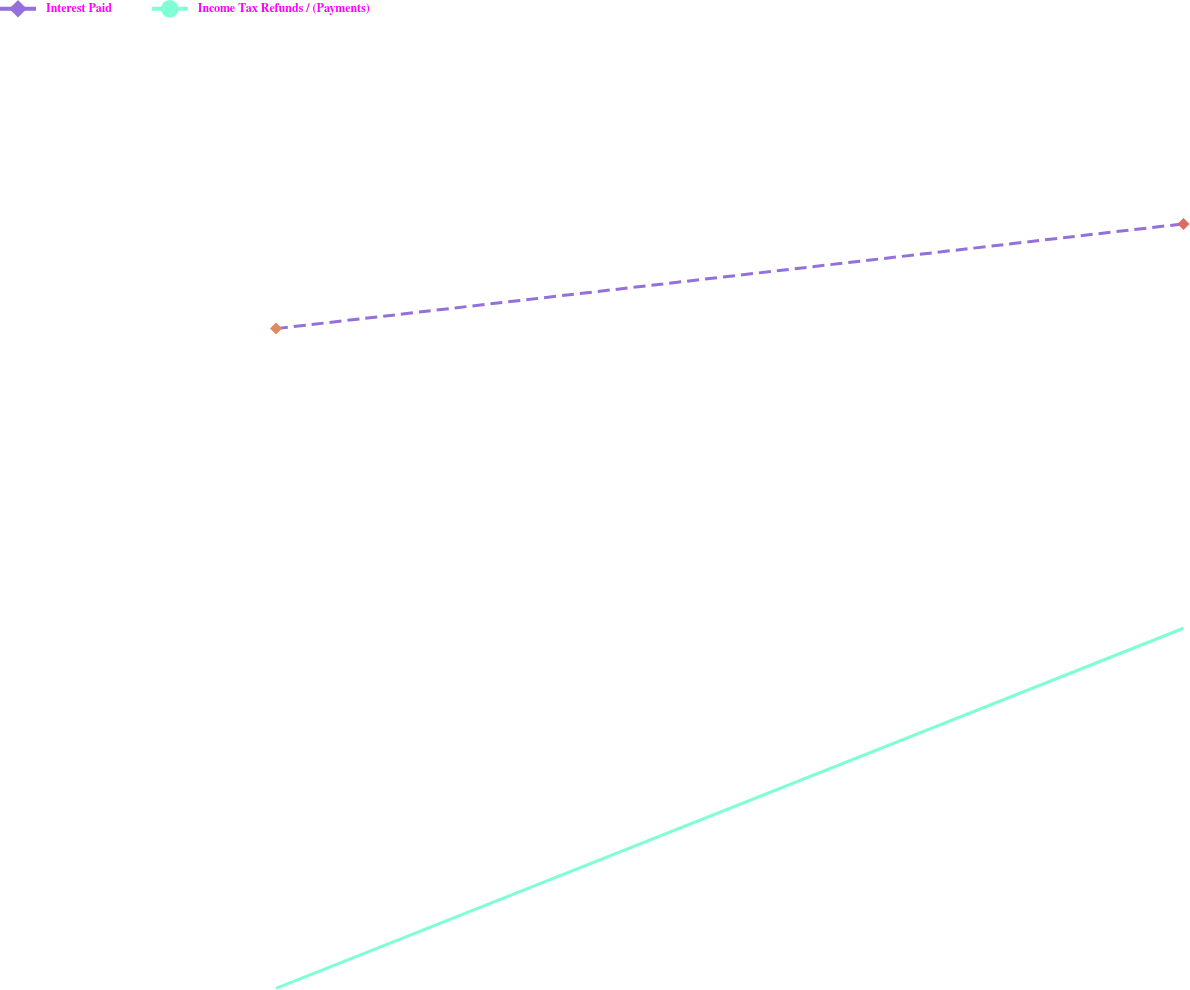Convert chart. <chart><loc_0><loc_0><loc_500><loc_500><line_chart><ecel><fcel>Interest Paid<fcel>Income Tax Refunds / (Payments)<nl><fcel>1730.75<fcel>308.91<fcel>34.03<nl><fcel>1870.94<fcel>352.55<fcel>184.07<nl><fcel>1928.48<fcel>397.39<fcel>64.75<nl></chart> 